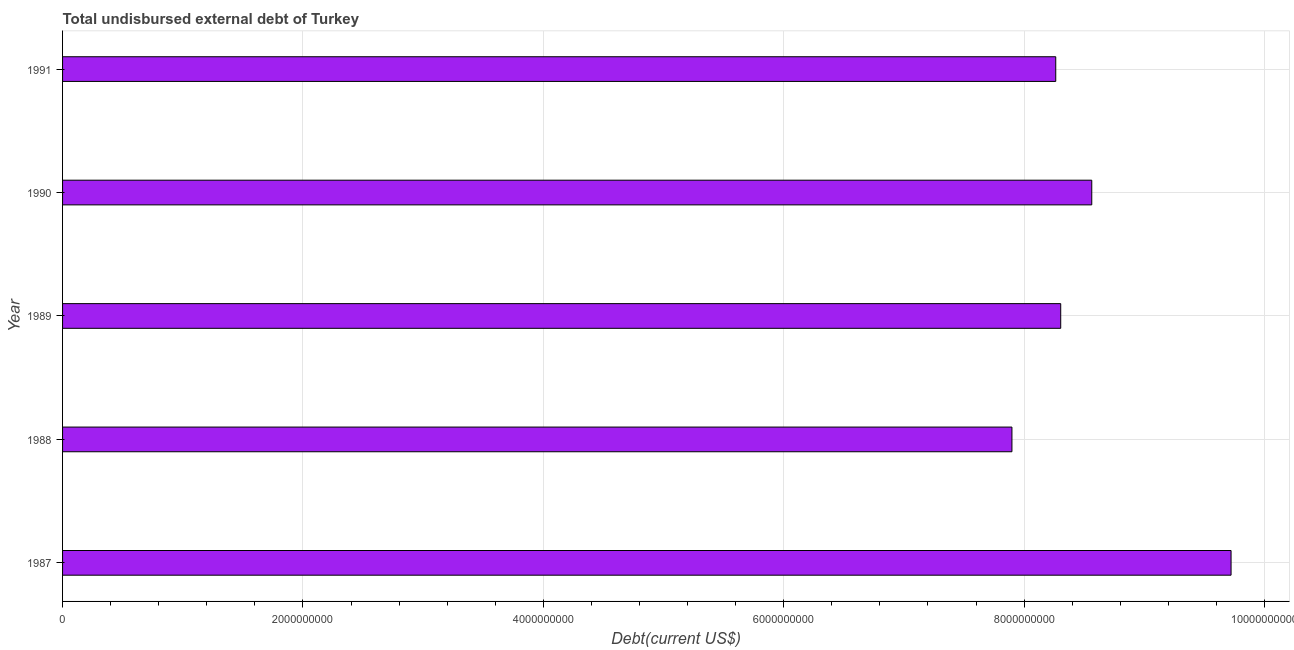What is the title of the graph?
Your answer should be very brief. Total undisbursed external debt of Turkey. What is the label or title of the X-axis?
Your answer should be very brief. Debt(current US$). What is the total debt in 1991?
Ensure brevity in your answer.  8.26e+09. Across all years, what is the maximum total debt?
Keep it short and to the point. 9.72e+09. Across all years, what is the minimum total debt?
Provide a short and direct response. 7.90e+09. In which year was the total debt maximum?
Make the answer very short. 1987. In which year was the total debt minimum?
Give a very brief answer. 1988. What is the sum of the total debt?
Provide a short and direct response. 4.28e+1. What is the difference between the total debt in 1990 and 1991?
Give a very brief answer. 3.00e+08. What is the average total debt per year?
Offer a very short reply. 8.55e+09. What is the median total debt?
Keep it short and to the point. 8.30e+09. In how many years, is the total debt greater than 5600000000 US$?
Your answer should be compact. 5. What is the ratio of the total debt in 1987 to that in 1988?
Your answer should be compact. 1.23. Is the total debt in 1987 less than that in 1989?
Your answer should be very brief. No. Is the difference between the total debt in 1989 and 1990 greater than the difference between any two years?
Your answer should be compact. No. What is the difference between the highest and the second highest total debt?
Provide a short and direct response. 1.16e+09. What is the difference between the highest and the lowest total debt?
Make the answer very short. 1.82e+09. In how many years, is the total debt greater than the average total debt taken over all years?
Your answer should be very brief. 2. How many bars are there?
Your response must be concise. 5. Are all the bars in the graph horizontal?
Ensure brevity in your answer.  Yes. Are the values on the major ticks of X-axis written in scientific E-notation?
Make the answer very short. No. What is the Debt(current US$) of 1987?
Offer a very short reply. 9.72e+09. What is the Debt(current US$) of 1988?
Your response must be concise. 7.90e+09. What is the Debt(current US$) of 1989?
Your answer should be compact. 8.30e+09. What is the Debt(current US$) of 1990?
Your answer should be compact. 8.56e+09. What is the Debt(current US$) in 1991?
Provide a succinct answer. 8.26e+09. What is the difference between the Debt(current US$) in 1987 and 1988?
Give a very brief answer. 1.82e+09. What is the difference between the Debt(current US$) in 1987 and 1989?
Ensure brevity in your answer.  1.42e+09. What is the difference between the Debt(current US$) in 1987 and 1990?
Make the answer very short. 1.16e+09. What is the difference between the Debt(current US$) in 1987 and 1991?
Your response must be concise. 1.46e+09. What is the difference between the Debt(current US$) in 1988 and 1989?
Ensure brevity in your answer.  -4.06e+08. What is the difference between the Debt(current US$) in 1988 and 1990?
Make the answer very short. -6.64e+08. What is the difference between the Debt(current US$) in 1988 and 1991?
Your answer should be compact. -3.64e+08. What is the difference between the Debt(current US$) in 1989 and 1990?
Give a very brief answer. -2.58e+08. What is the difference between the Debt(current US$) in 1989 and 1991?
Provide a short and direct response. 4.13e+07. What is the difference between the Debt(current US$) in 1990 and 1991?
Offer a terse response. 3.00e+08. What is the ratio of the Debt(current US$) in 1987 to that in 1988?
Your answer should be very brief. 1.23. What is the ratio of the Debt(current US$) in 1987 to that in 1989?
Your answer should be compact. 1.17. What is the ratio of the Debt(current US$) in 1987 to that in 1990?
Your answer should be very brief. 1.14. What is the ratio of the Debt(current US$) in 1987 to that in 1991?
Ensure brevity in your answer.  1.18. What is the ratio of the Debt(current US$) in 1988 to that in 1989?
Provide a short and direct response. 0.95. What is the ratio of the Debt(current US$) in 1988 to that in 1990?
Make the answer very short. 0.92. What is the ratio of the Debt(current US$) in 1988 to that in 1991?
Offer a terse response. 0.96. What is the ratio of the Debt(current US$) in 1989 to that in 1991?
Give a very brief answer. 1. What is the ratio of the Debt(current US$) in 1990 to that in 1991?
Make the answer very short. 1.04. 